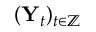<formula> <loc_0><loc_0><loc_500><loc_500>( Y _ { t } ) _ { t \in \mathbb { Z } }</formula> 